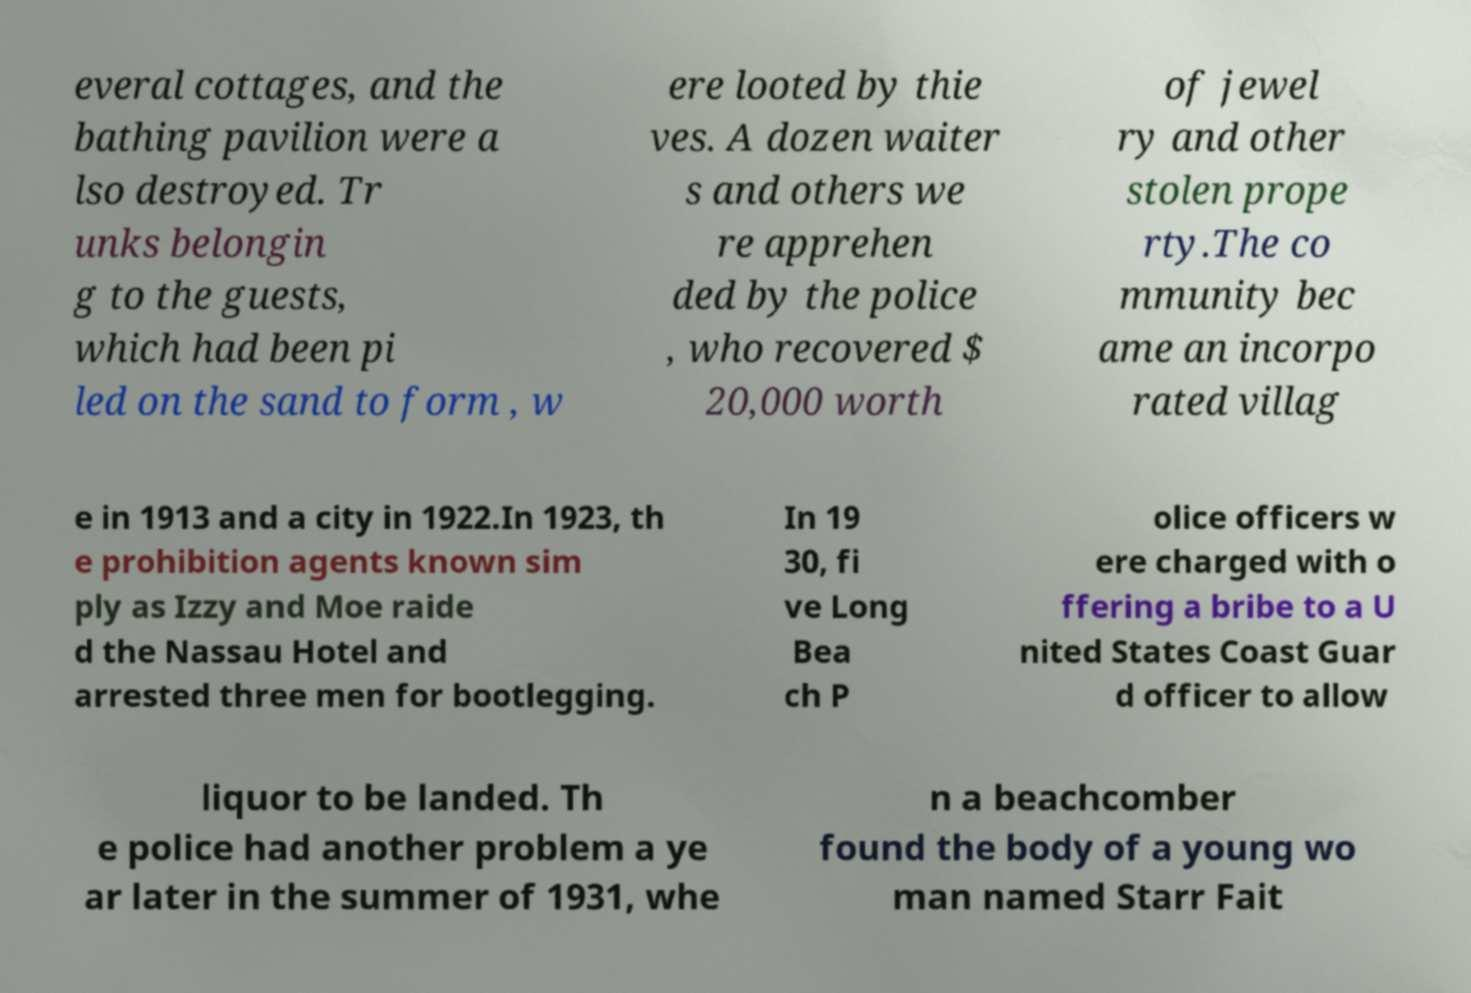Please identify and transcribe the text found in this image. everal cottages, and the bathing pavilion were a lso destroyed. Tr unks belongin g to the guests, which had been pi led on the sand to form , w ere looted by thie ves. A dozen waiter s and others we re apprehen ded by the police , who recovered $ 20,000 worth of jewel ry and other stolen prope rty.The co mmunity bec ame an incorpo rated villag e in 1913 and a city in 1922.In 1923, th e prohibition agents known sim ply as Izzy and Moe raide d the Nassau Hotel and arrested three men for bootlegging. In 19 30, fi ve Long Bea ch P olice officers w ere charged with o ffering a bribe to a U nited States Coast Guar d officer to allow liquor to be landed. Th e police had another problem a ye ar later in the summer of 1931, whe n a beachcomber found the body of a young wo man named Starr Fait 